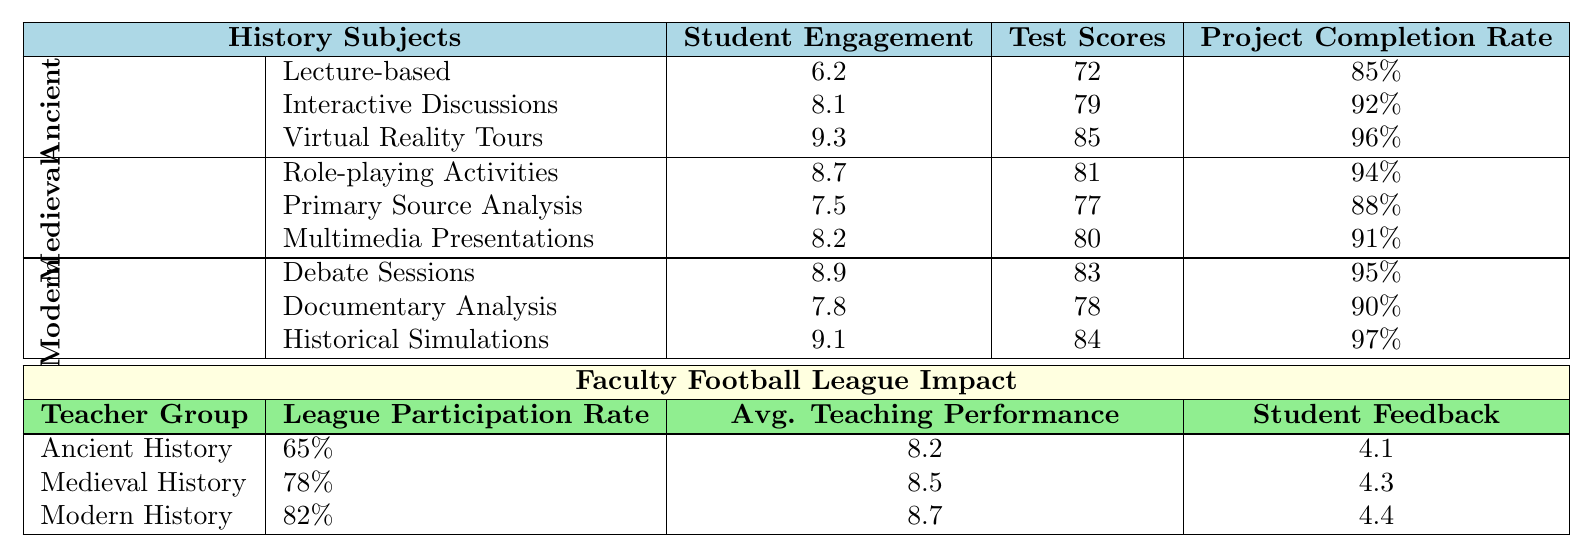What is the highest student engagement score among teaching strategies for Ancient History? The teaching strategies for Ancient History are Lecture-based (6.2), Interactive Discussions (8.1), and Virtual Reality Tours (9.3). The highest score is from Virtual Reality Tours.
Answer: 9.3 Which Medieval History teaching strategy has the lowest test scores? The test scores for the teaching strategies in Medieval History are 81 for Role-playing Activities, 77 for Primary Source Analysis, and 80 for Multimedia Presentations. The lowest is from Primary Source Analysis.
Answer: 77 What is the project completion rate for Historical Simulations in Modern History? The project completion rate for Historical Simulations is listed as 97% in the table.
Answer: 97% Which history subject's teachers have the highest league participation rate? The league participation rates for the History subjects are 65% for Ancient, 78% for Medieval, and 82% for Modern History. The highest rate is for Modern History teachers.
Answer: 82% What is the average teaching performance score for Medieval History teachers? The table states that the average teaching performance score for Medieval History teachers is 8.5.
Answer: 8.5 Did teachers from Ancient History have a higher or lower student feedback score than those from Modern History? The student feedback scores are 4.1 for Ancient and 4.4 for Modern History teachers. Since 4.1 is lower than 4.4, Ancient History teachers had a lower score.
Answer: Lower What is the difference in student engagement between the best and worst teaching strategies for Modern History? The highest student engagement in Modern History is 9.1 from Historical Simulations, while the lowest is 7.8 from Documentary Analysis. The difference is 9.1 - 7.8 = 1.3.
Answer: 1.3 Which teaching strategy across all history subjects yielded the highest project completion rate? The project completion rates are 96% for Virtual Reality Tours (Ancient), 94% for Role-playing Activities (Medieval), and 97% for Historical Simulations (Modern). The highest is 97% from Historical Simulations.
Answer: 97% What is the average participation rate of teachers from all history subjects in the Faculty Football League? The participation rates are 65% for Ancient, 78% for Medieval, and 82% for Modern History. The average is (65 + 78 + 82) / 3 = 75%.
Answer: 75% Which teaching strategy should Ancient History teachers adopt to increase student engagement based on the data? The student engagement score for Virtual Reality Tours is 9.3, higher than other strategies in Ancient History. Therefore, adopting this strategy would likely increase engagement.
Answer: Virtual Reality Tours 